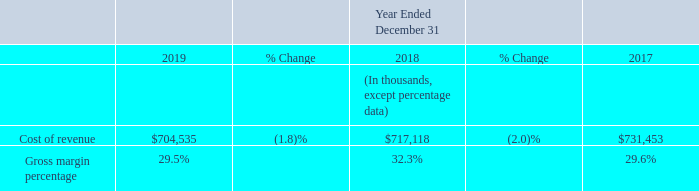2019 vs 2018
Cost of revenue decreased for the year ended December 31, 2019, compared to the prior year, primarily due to net revenue declining.
Gross margin decreased for the year ended December 31, 2019 compared to the prior year. Gross margin was negatively impacted by the imposition of Section 301 tariffs originally announced in late 2018 and cost inefficiencies experienced in our new manufacturing locations outside of China, an increase in channel promotional activities relative to revenue as well as foreign exchange headwinds due to the strengthening of the U.S. dollar.
2018 vs 2017
Cost of revenue decreased for the year ended December 31, 2018 primarily due to improved product margin performance, lower proportionate provisions for warranty expense, and lower air freight costs compared to the prior year.
Gross margin increased for the year ended December 31, 2018 compared to the prior year primarily due to improved product margin performance, lower proportionate provisions for sales returns and warranty expense, favorable foreign exchange rate movements and lower air freight costs compared to the prior year.
For fiscal 2020, we expect gross margins to improve from fiscal 2019 primarily as our U.S. bound inventory will primarily not be subject to Section 301 tariffs in fiscal 2020. Forecasting gross margin percentages is difficult, and there are a number of risks related to our ability to maintain or improve our current gross margin levels. Our cost of revenue as a percentage of net revenue can vary significantly based upon factors such as: uncertainties surrounding revenue levels, including future pricing and/or potential discounts as a result of the economy or in response to the strengthening of the U.S. dollar in our international markets, and related production level variances; import customs duties and imposed tariffs; competition; changes in technology; changes in product mix; variability of stockbased compensation costs; royalties to third parties; fluctuations in freight and repair costs; manufacturing and purchase price variances; changes in prices on commodity components; warranty costs; and the timing of sales, particularly to service provider customers. We expect that revenue derived from paid subscription service plans will increase in the future, which may have a positive impact on our gross margin. From time to time, however, we may experience fluctuations in our gross margin as a result of the factors discussed above.
What accounted for the change in gross margin from 2017 to 2018? Due to improved product margin performance, lower proportionate provisions for sales returns and warranty expense, favorable foreign exchange rate movements and lower air freight costs compared to the prior year. What was the cost of revenue in 2019?
Answer scale should be: thousand. $704,535. What accounted for the change in cost of revenue from 2018 to 2019? Due to net revenue declining. Which year has the highest gross margin percentage? 32.3% > 29.6% > 29.5%
Answer: 2018. What is the gross margin percentage change from 2017 to 2018?
Answer scale should be: percent. 32.3%-29.6% 
Answer: 2.7. What was the percentage change in cost of revenue from 2017 to 2019?
Answer scale should be: percent. (704,535-731,453)/731,453 
Answer: -3.68. 